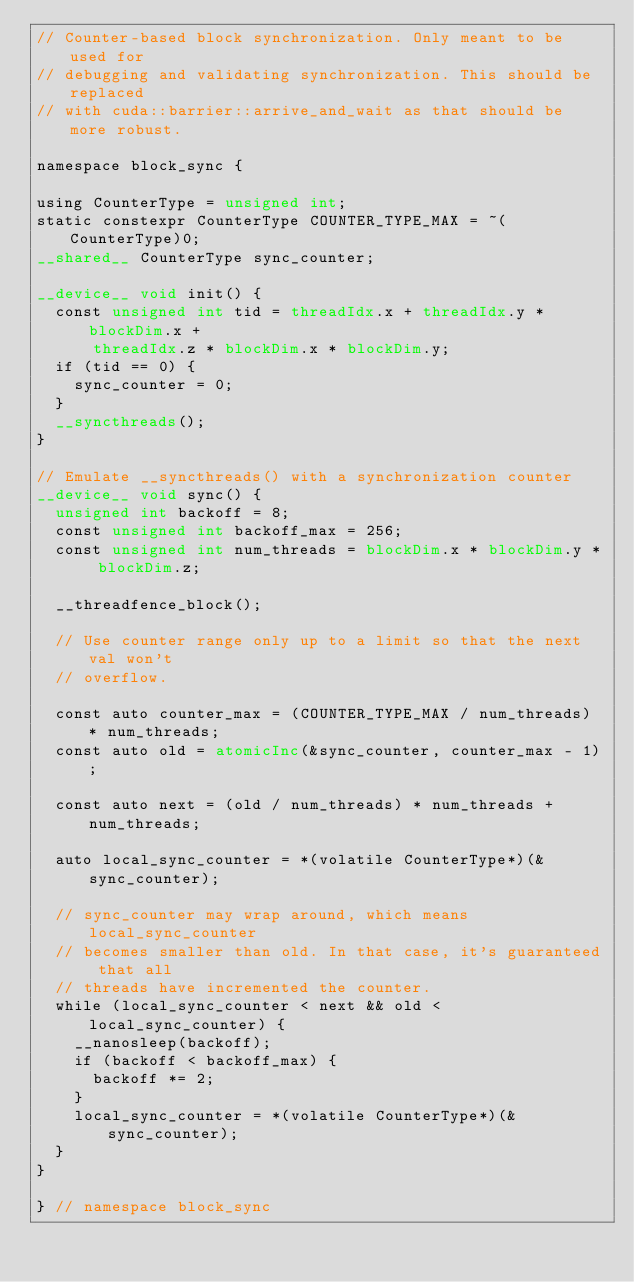<code> <loc_0><loc_0><loc_500><loc_500><_Cuda_>// Counter-based block synchronization. Only meant to be used for
// debugging and validating synchronization. This should be replaced
// with cuda::barrier::arrive_and_wait as that should be more robust.

namespace block_sync {

using CounterType = unsigned int;
static constexpr CounterType COUNTER_TYPE_MAX = ~(CounterType)0;
__shared__ CounterType sync_counter;

__device__ void init() {
  const unsigned int tid = threadIdx.x + threadIdx.y * blockDim.x +
      threadIdx.z * blockDim.x * blockDim.y;
  if (tid == 0) {
    sync_counter = 0;
  }
  __syncthreads();
}

// Emulate __syncthreads() with a synchronization counter
__device__ void sync() {
  unsigned int backoff = 8;
  const unsigned int backoff_max = 256;
  const unsigned int num_threads = blockDim.x * blockDim.y * blockDim.z;

  __threadfence_block();

  // Use counter range only up to a limit so that the next val won't
  // overflow.

  const auto counter_max = (COUNTER_TYPE_MAX / num_threads) * num_threads;
  const auto old = atomicInc(&sync_counter, counter_max - 1);

  const auto next = (old / num_threads) * num_threads + num_threads;

  auto local_sync_counter = *(volatile CounterType*)(&sync_counter);

  // sync_counter may wrap around, which means local_sync_counter
  // becomes smaller than old. In that case, it's guaranteed that all
  // threads have incremented the counter.
  while (local_sync_counter < next && old < local_sync_counter) {
    __nanosleep(backoff);
    if (backoff < backoff_max) {
      backoff *= 2;
    }
    local_sync_counter = *(volatile CounterType*)(&sync_counter);
  }
}

} // namespace block_sync
</code> 